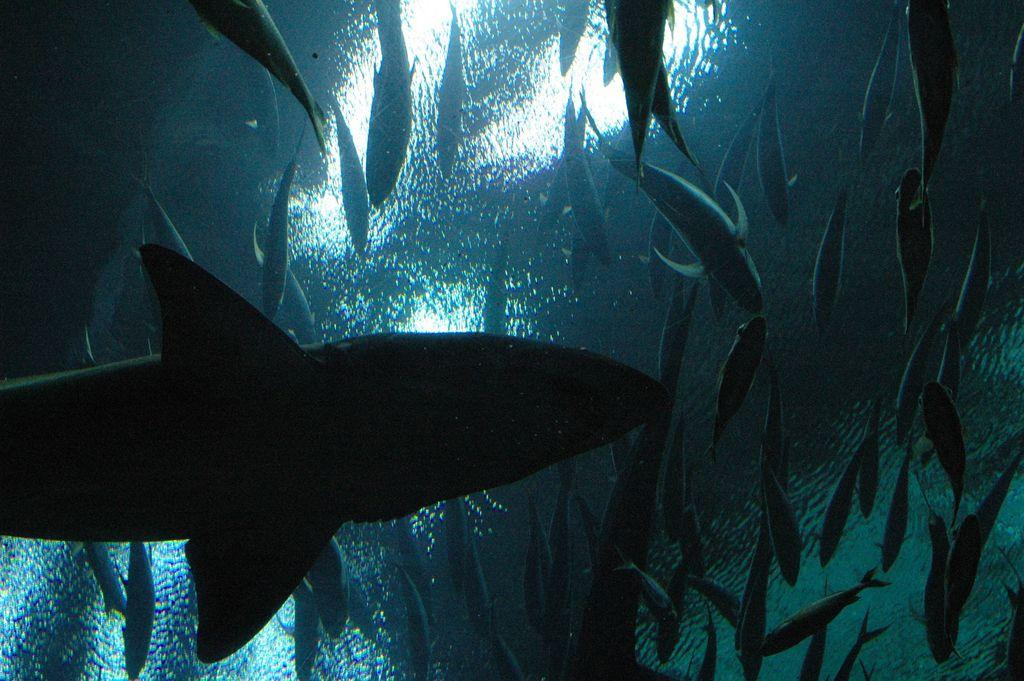What type of animals can be seen in the image? There are fish in the water. Can you describe the perspective of the image? The image appears to be taken from inside the water. What type of meat can be seen hanging from the trees in the image? There is no meat present in the image; it features fish in the water. How many cars can be seen driving through the water in the image? There are no cars present in the image; it is taken from inside the water and features fish. 